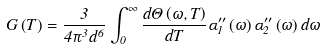<formula> <loc_0><loc_0><loc_500><loc_500>G \left ( T \right ) = \frac { 3 } { 4 \pi ^ { 3 } d ^ { 6 } } \int _ { 0 } ^ { \infty } \frac { d \Theta \left ( \omega , T \right ) } { d T } \alpha _ { 1 } ^ { \prime \prime } \left ( \omega \right ) \alpha _ { 2 } ^ { \prime \prime } \left ( \omega \right ) d \omega</formula> 